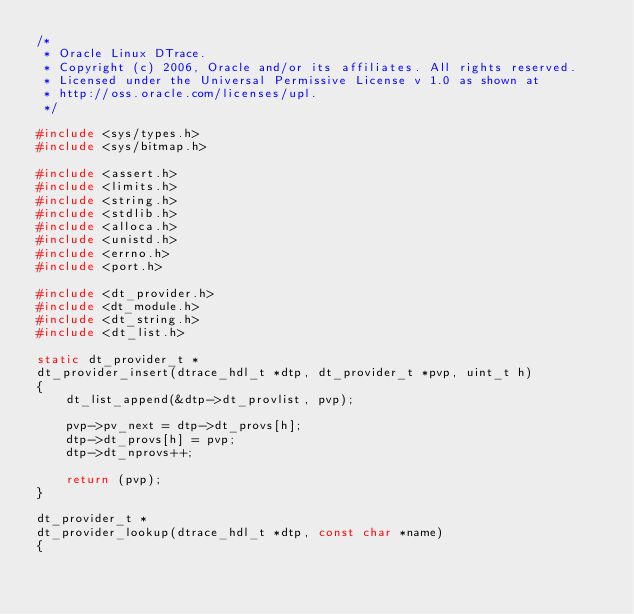<code> <loc_0><loc_0><loc_500><loc_500><_C_>/*
 * Oracle Linux DTrace.
 * Copyright (c) 2006, Oracle and/or its affiliates. All rights reserved.
 * Licensed under the Universal Permissive License v 1.0 as shown at
 * http://oss.oracle.com/licenses/upl.
 */

#include <sys/types.h>
#include <sys/bitmap.h>

#include <assert.h>
#include <limits.h>
#include <string.h>
#include <stdlib.h>
#include <alloca.h>
#include <unistd.h>
#include <errno.h>
#include <port.h>

#include <dt_provider.h>
#include <dt_module.h>
#include <dt_string.h>
#include <dt_list.h>

static dt_provider_t *
dt_provider_insert(dtrace_hdl_t *dtp, dt_provider_t *pvp, uint_t h)
{
	dt_list_append(&dtp->dt_provlist, pvp);

	pvp->pv_next = dtp->dt_provs[h];
	dtp->dt_provs[h] = pvp;
	dtp->dt_nprovs++;

	return (pvp);
}

dt_provider_t *
dt_provider_lookup(dtrace_hdl_t *dtp, const char *name)
{</code> 